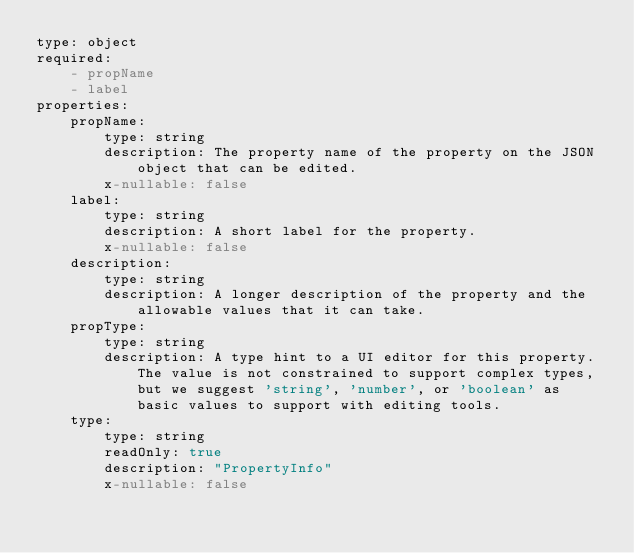<code> <loc_0><loc_0><loc_500><loc_500><_YAML_>type: object
required:
    - propName
    - label
properties:
    propName:
        type: string
        description: The property name of the property on the JSON object that can be edited.
        x-nullable: false
    label:
        type: string
        description: A short label for the property.
        x-nullable: false
    description:
        type: string
        description: A longer description of the property and the allowable values that it can take.
    propType:
        type: string
        description: A type hint to a UI editor for this property. The value is not constrained to support complex types, but we suggest 'string', 'number', or 'boolean' as basic values to support with editing tools.
    type:
        type: string
        readOnly: true
        description: "PropertyInfo"
        x-nullable: false
</code> 